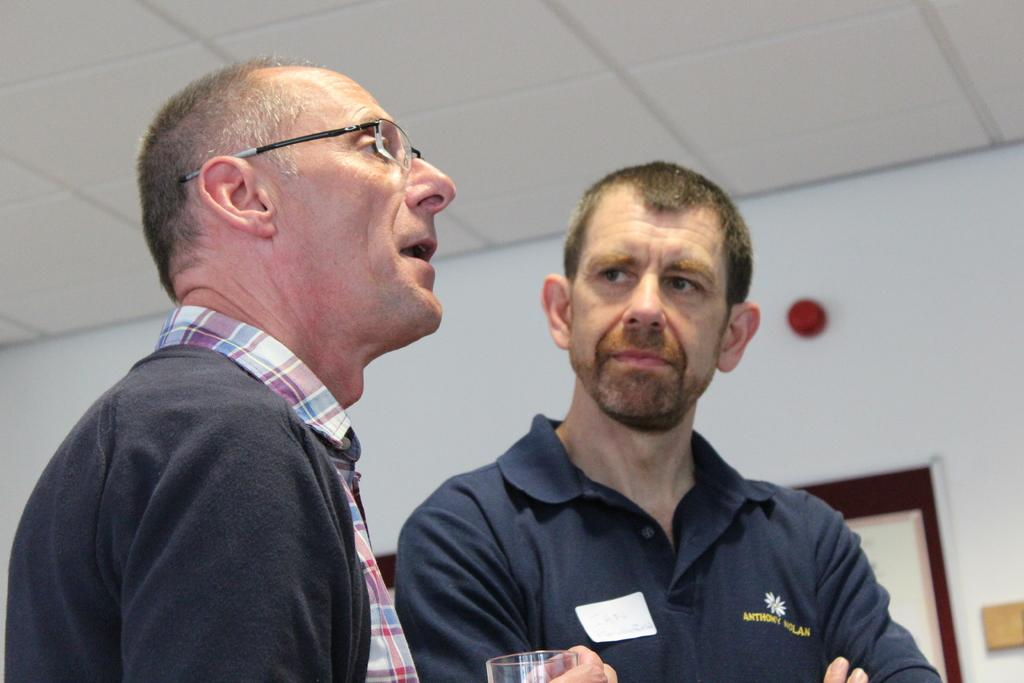How many people are in the foreground of the image? There are two men standing in the foreground of the image. What is one of the men holding in the image? One man is holding a glass in the image. What can be seen on the wall in the background of the image? There is a board on the wall in the background of the image. What is visible at the top of the image? The ceiling is visible at the top of the image. What type of bait is the man holding in the image? There is no bait present in the image; one man is holding a glass. Can you read the letter on the board in the background of the image? There is no letter on the board in the background of the image; it only mentions that there is a board present. 